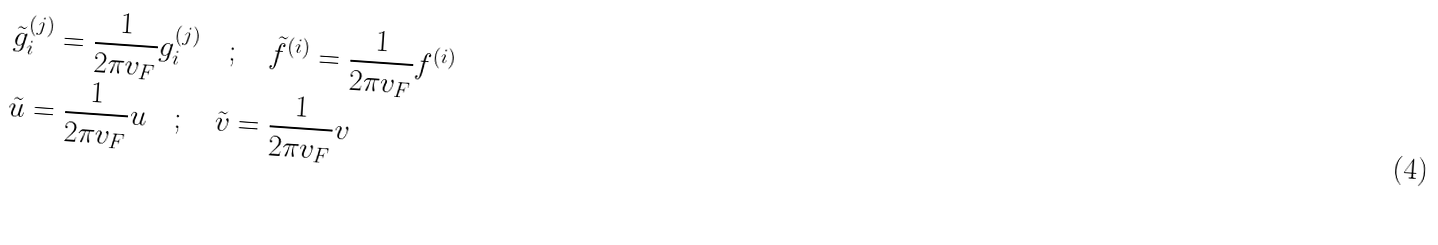Convert formula to latex. <formula><loc_0><loc_0><loc_500><loc_500>& \tilde { g } _ { i } ^ { ( j ) } = \frac { 1 } { 2 \pi v _ { F } } g _ { i } ^ { ( j ) } \quad ; \quad \tilde { f } ^ { ( i ) } = \frac { 1 } { 2 \pi v _ { F } } f ^ { ( i ) } \\ & \tilde { u } = \frac { 1 } { 2 \pi v _ { F } } u \quad ; \quad \tilde { v } = \frac { 1 } { 2 \pi v _ { F } } v</formula> 